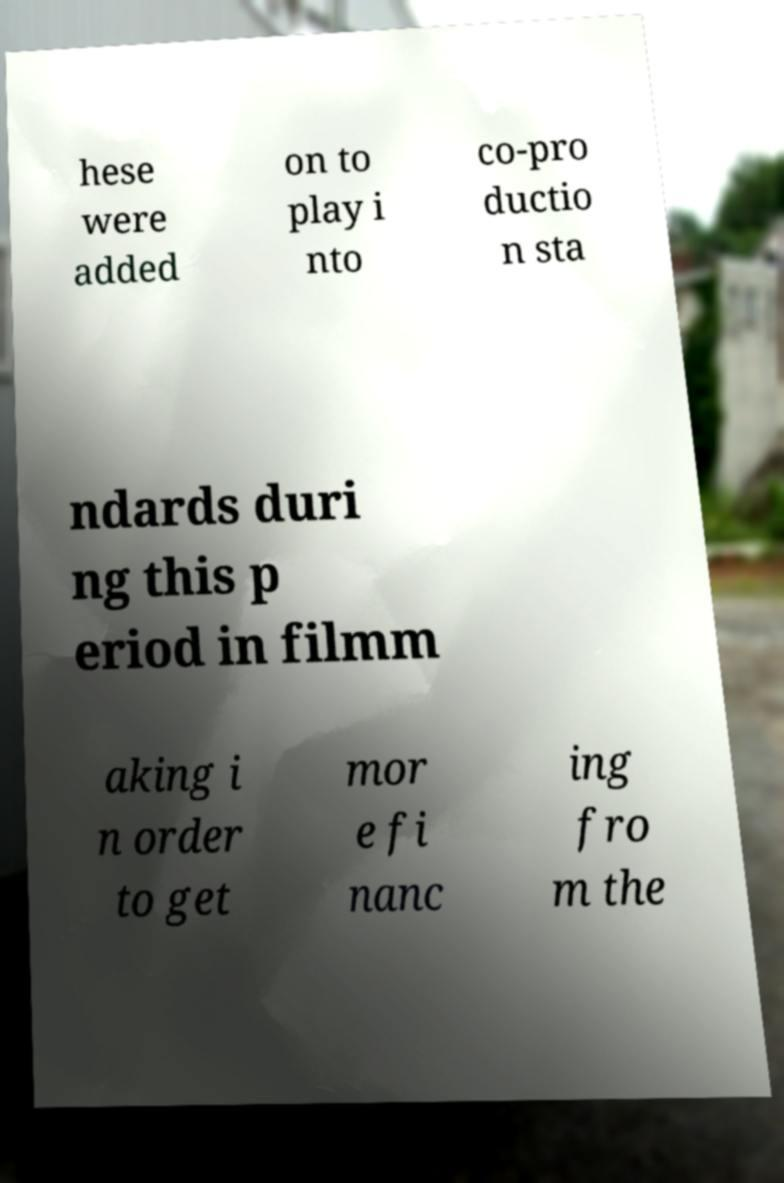There's text embedded in this image that I need extracted. Can you transcribe it verbatim? hese were added on to play i nto co-pro ductio n sta ndards duri ng this p eriod in filmm aking i n order to get mor e fi nanc ing fro m the 